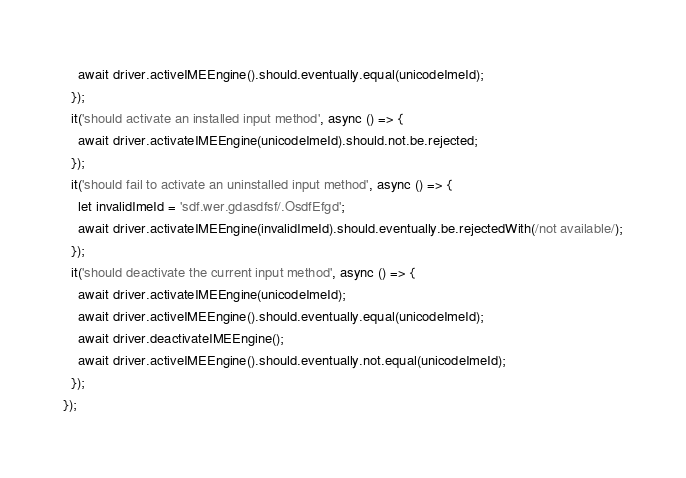<code> <loc_0><loc_0><loc_500><loc_500><_JavaScript_>    await driver.activeIMEEngine().should.eventually.equal(unicodeImeId);
  });
  it('should activate an installed input method', async () => {
    await driver.activateIMEEngine(unicodeImeId).should.not.be.rejected;
  });
  it('should fail to activate an uninstalled input method', async () => {
    let invalidImeId = 'sdf.wer.gdasdfsf/.OsdfEfgd';
    await driver.activateIMEEngine(invalidImeId).should.eventually.be.rejectedWith(/not available/);
  });
  it('should deactivate the current input method', async () => {
    await driver.activateIMEEngine(unicodeImeId);
    await driver.activeIMEEngine().should.eventually.equal(unicodeImeId);
    await driver.deactivateIMEEngine();
    await driver.activeIMEEngine().should.eventually.not.equal(unicodeImeId);
  });
});
</code> 